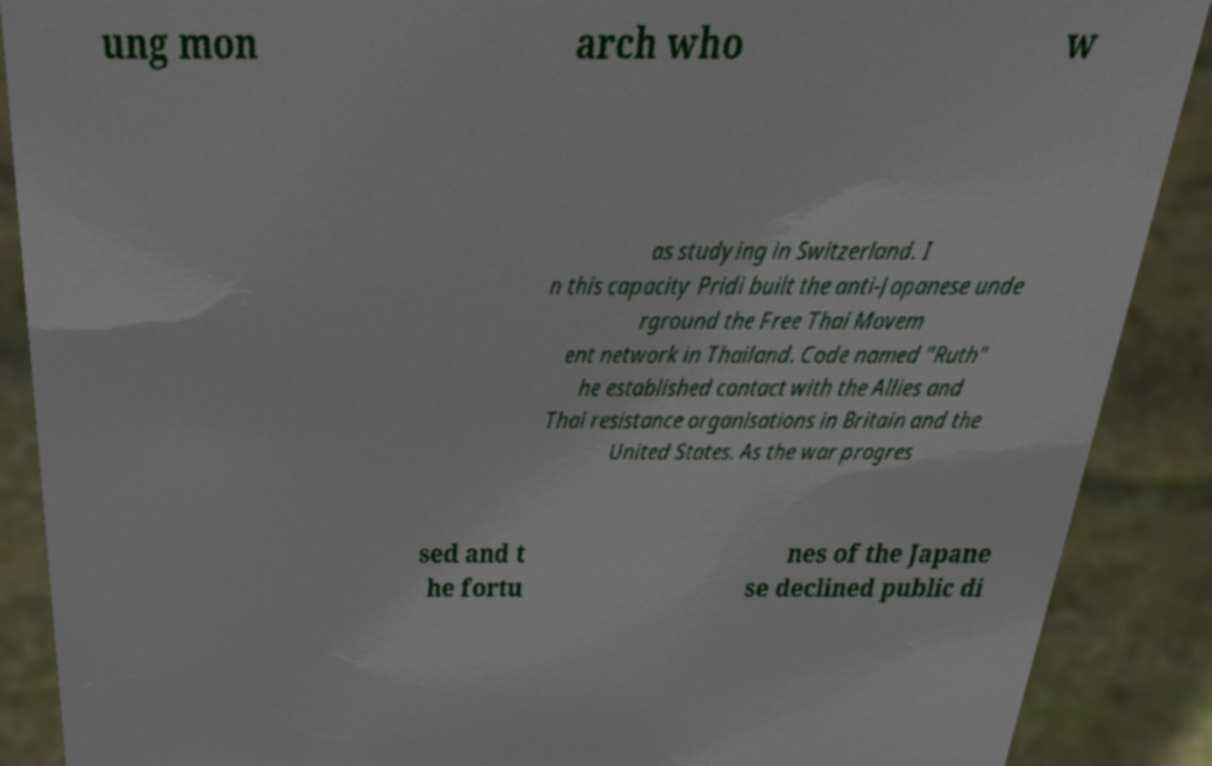Can you accurately transcribe the text from the provided image for me? ung mon arch who w as studying in Switzerland. I n this capacity Pridi built the anti-Japanese unde rground the Free Thai Movem ent network in Thailand. Code named "Ruth" he established contact with the Allies and Thai resistance organisations in Britain and the United States. As the war progres sed and t he fortu nes of the Japane se declined public di 